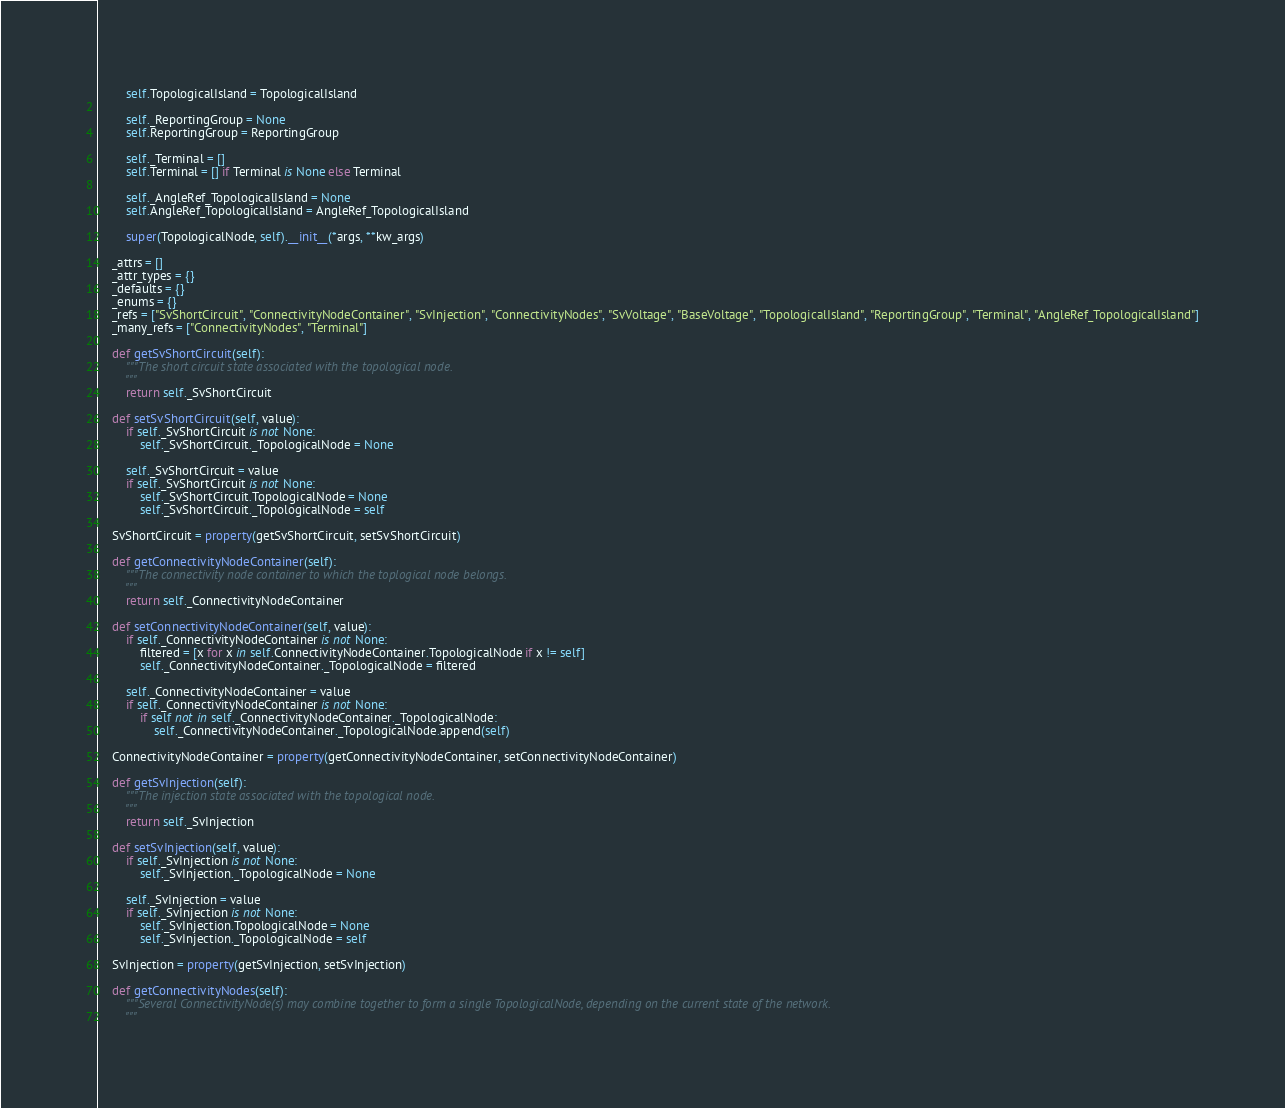Convert code to text. <code><loc_0><loc_0><loc_500><loc_500><_Python_>        self.TopologicalIsland = TopologicalIsland

        self._ReportingGroup = None
        self.ReportingGroup = ReportingGroup

        self._Terminal = []
        self.Terminal = [] if Terminal is None else Terminal

        self._AngleRef_TopologicalIsland = None
        self.AngleRef_TopologicalIsland = AngleRef_TopologicalIsland

        super(TopologicalNode, self).__init__(*args, **kw_args)

    _attrs = []
    _attr_types = {}
    _defaults = {}
    _enums = {}
    _refs = ["SvShortCircuit", "ConnectivityNodeContainer", "SvInjection", "ConnectivityNodes", "SvVoltage", "BaseVoltage", "TopologicalIsland", "ReportingGroup", "Terminal", "AngleRef_TopologicalIsland"]
    _many_refs = ["ConnectivityNodes", "Terminal"]

    def getSvShortCircuit(self):
        """The short circuit state associated with the topological node.
        """
        return self._SvShortCircuit

    def setSvShortCircuit(self, value):
        if self._SvShortCircuit is not None:
            self._SvShortCircuit._TopologicalNode = None

        self._SvShortCircuit = value
        if self._SvShortCircuit is not None:
            self._SvShortCircuit.TopologicalNode = None
            self._SvShortCircuit._TopologicalNode = self

    SvShortCircuit = property(getSvShortCircuit, setSvShortCircuit)

    def getConnectivityNodeContainer(self):
        """The connectivity node container to which the toplogical node belongs.
        """
        return self._ConnectivityNodeContainer

    def setConnectivityNodeContainer(self, value):
        if self._ConnectivityNodeContainer is not None:
            filtered = [x for x in self.ConnectivityNodeContainer.TopologicalNode if x != self]
            self._ConnectivityNodeContainer._TopologicalNode = filtered

        self._ConnectivityNodeContainer = value
        if self._ConnectivityNodeContainer is not None:
            if self not in self._ConnectivityNodeContainer._TopologicalNode:
                self._ConnectivityNodeContainer._TopologicalNode.append(self)

    ConnectivityNodeContainer = property(getConnectivityNodeContainer, setConnectivityNodeContainer)

    def getSvInjection(self):
        """The injection state associated with the topological node.
        """
        return self._SvInjection

    def setSvInjection(self, value):
        if self._SvInjection is not None:
            self._SvInjection._TopologicalNode = None

        self._SvInjection = value
        if self._SvInjection is not None:
            self._SvInjection.TopologicalNode = None
            self._SvInjection._TopologicalNode = self

    SvInjection = property(getSvInjection, setSvInjection)

    def getConnectivityNodes(self):
        """Several ConnectivityNode(s) may combine together to form a single TopologicalNode, depending on the current state of the network.
        """</code> 